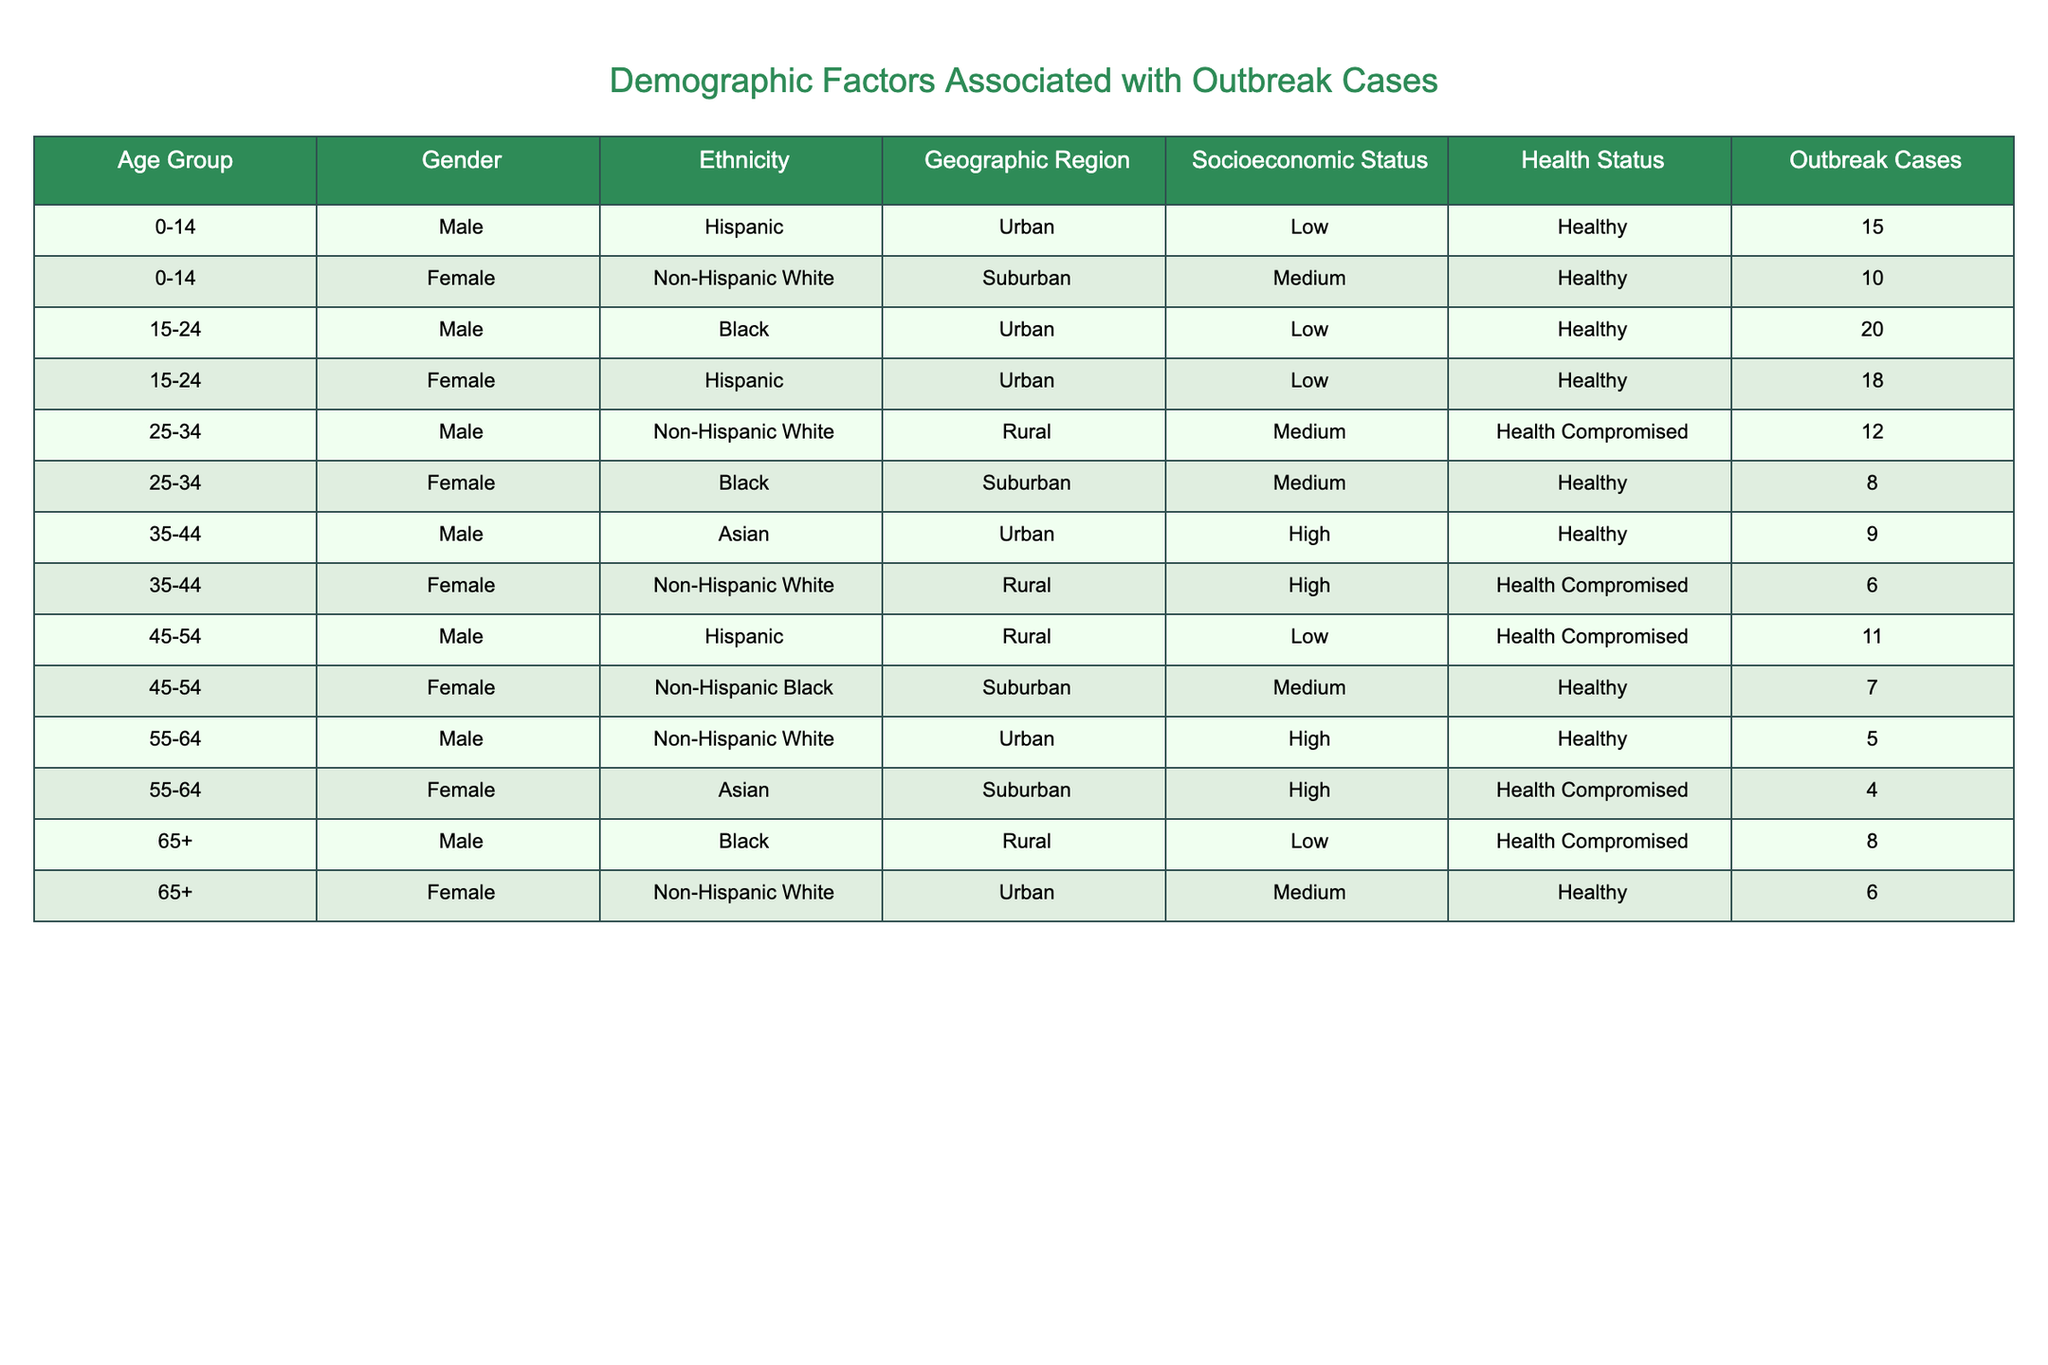What is the total number of outbreak cases among individuals aged 25-34? To find the total outbreak cases for the age group 25-34, I can refer to the table and add the outbreak cases for both males and females in this age group. The males have 12 cases, and the females have 8 cases. So, 12 + 8 = 20.
Answer: 20 Is there a higher number of outbreak cases in the Urban geographic region compared to the Rural region? To answer this, I can count the outbreak cases in both Urban and Rural regions. In Urban, there are: 15 + 20 + 18 + 9 + 5 + 6 = 73 cases. In Rural, there are: 12 + 6 + 11 + 8 = 37 cases. Since 73 is greater than 37, the answer is yes.
Answer: Yes What is the average number of outbreak cases for females across all age groups? To calculate the average for females, I need to sum up the outbreak cases for all female entries and then divide by the number of female entries. The female cases are: 10 + 18 + 8 + 6 + 4 + 6 = 52. There are 6 female entries, so the average is 52 / 6 = 8.67.
Answer: 8.67 How many outbreak cases are reported for individuals with a low socioeconomic status? I will look at the entries where socioeconomic status is low and sum the outbreak cases. The cases are: 15 (0-14, Male) + 20 (15-24, Male) + 12 (25-34, Male) + 11 (45-54, Male) + 8 (65+, Male) = 66.
Answer: 66 Are there more outbreak cases among males with compromised health compared to females with healthy status? First, I need to sum the outbreak cases for males with compromised health: 12 (25-34) + 6 (35-44) + 11 (45-54) + 8 (65+) = 37. Now, for females with a healthy status: 10 (0-14) + 18 (15-24) + 8 (25-34) + 7 (45-54) + 6 (65+) = 49. Since 37 is less than 49, the answer is no.
Answer: No 